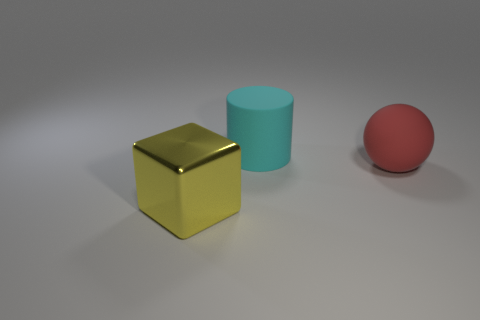Are there more red rubber balls than small cylinders?
Your answer should be very brief. Yes. Do the large object that is behind the big red object and the big sphere have the same material?
Your answer should be very brief. Yes. Are there fewer large red cubes than large metallic objects?
Offer a terse response. Yes. Are there any matte objects that are in front of the rubber object behind the rubber object that is on the right side of the cyan object?
Offer a very short reply. Yes. Are there more large objects to the left of the large red object than tiny yellow shiny objects?
Provide a succinct answer. Yes. There is a thing behind the matte thing that is in front of the object behind the big red object; what is its color?
Your answer should be very brief. Cyan. How many cyan objects have the same size as the yellow metallic thing?
Make the answer very short. 1. Is the material of the big object that is behind the big red thing the same as the object that is left of the cylinder?
Your answer should be very brief. No. Are there any other things that have the same shape as the red matte object?
Your answer should be compact. No. The big ball has what color?
Offer a terse response. Red. 